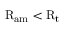<formula> <loc_0><loc_0><loc_500><loc_500>R _ { a m } < R _ { t }</formula> 